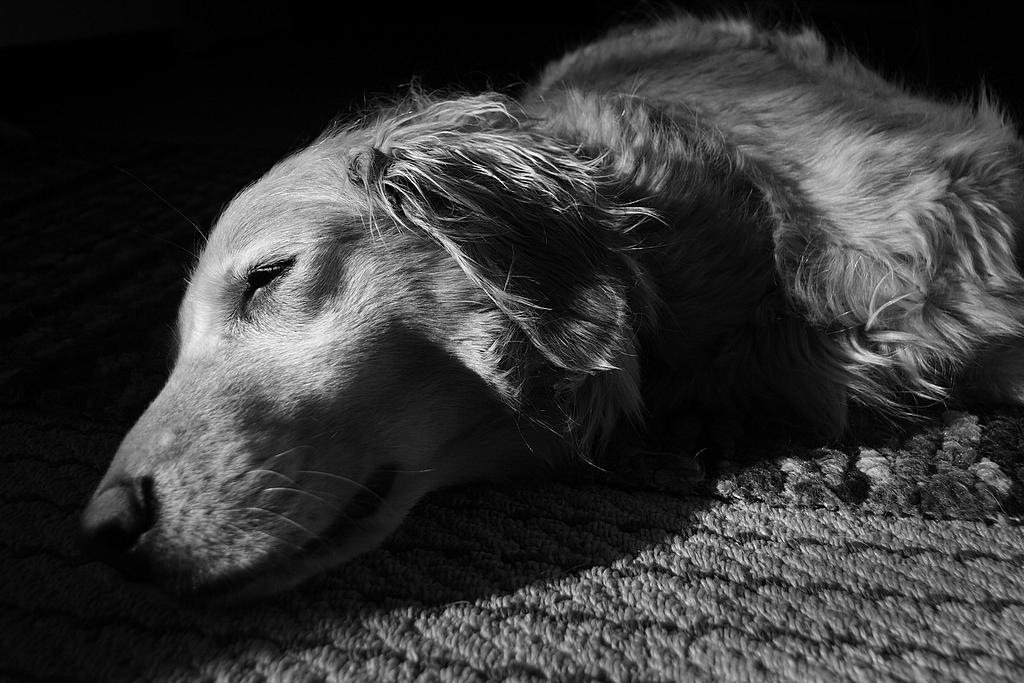What animal is present in the image? There is a dog in the image. What is the dog doing in the image? The dog is sleeping. Where is the dog located in the image? The dog is on a mat. What type of church can be seen in the background of the image? There is no church present in the image; it features a dog sleeping on a mat. What kind of vessel is the dog using to sail in the image? There is no vessel present in the image; it features a dog sleeping on a mat. 